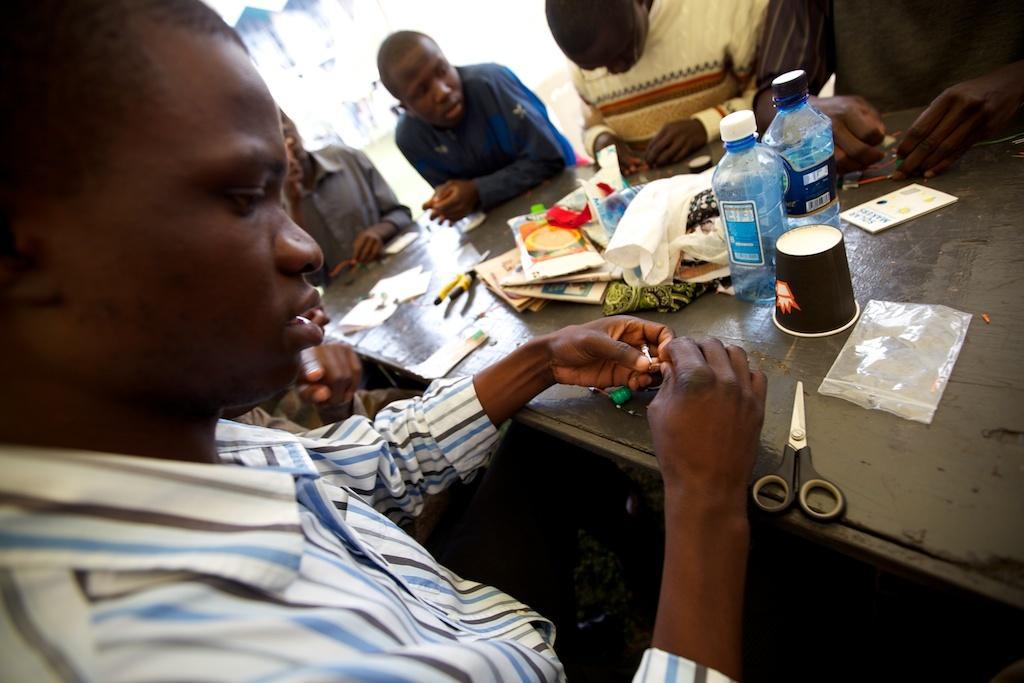Describe this image in one or two sentences. As we can see in the image there are few people sitting on chairs and there is a table over here. On table there are scissors, cover, glass, bottles, book, tissues and papers. 